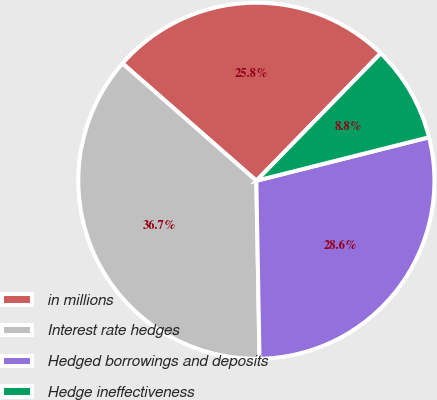<chart> <loc_0><loc_0><loc_500><loc_500><pie_chart><fcel>in millions<fcel>Interest rate hedges<fcel>Hedged borrowings and deposits<fcel>Hedge ineffectiveness<nl><fcel>25.85%<fcel>36.74%<fcel>28.65%<fcel>8.77%<nl></chart> 